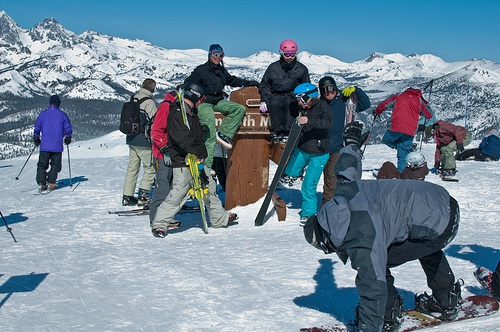Describe the objects in this image and their specific colors. I can see people in teal, black, gray, and blue tones, people in teal, black, darkgray, gray, and blue tones, people in teal and black tones, people in teal and black tones, and people in teal, darkgray, black, gray, and darkblue tones in this image. 